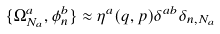<formula> <loc_0><loc_0><loc_500><loc_500>\{ \Omega ^ { a } _ { N _ { a } } , \phi ^ { b } _ { n } \} \approx \eta ^ { a } ( q , p ) \delta ^ { a b } \delta _ { n , { N _ { a } } }</formula> 